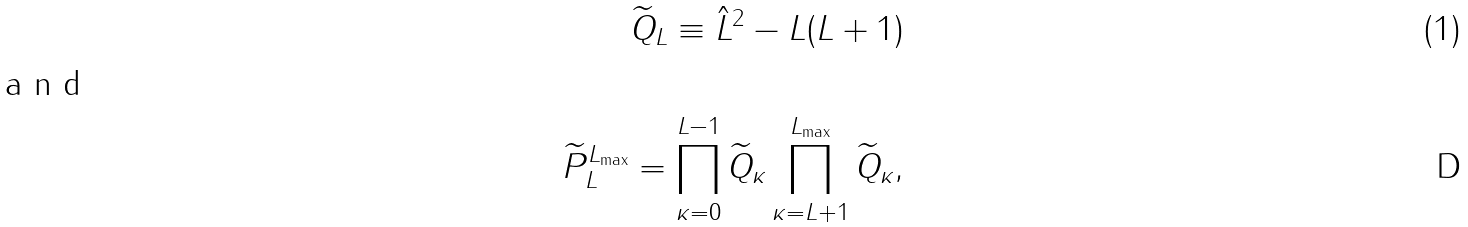Convert formula to latex. <formula><loc_0><loc_0><loc_500><loc_500>\widetilde { Q } _ { L } \equiv \hat { L } ^ { 2 } - L ( L + 1 ) \intertext { a n d } \widetilde { P } ^ { L _ { \max } } _ { L } = \prod _ { \kappa = 0 } ^ { L - 1 } \widetilde { Q } _ { \kappa } \prod _ { \kappa = L + 1 } ^ { L _ { \max } } \widetilde { Q } _ { \kappa } ,</formula> 